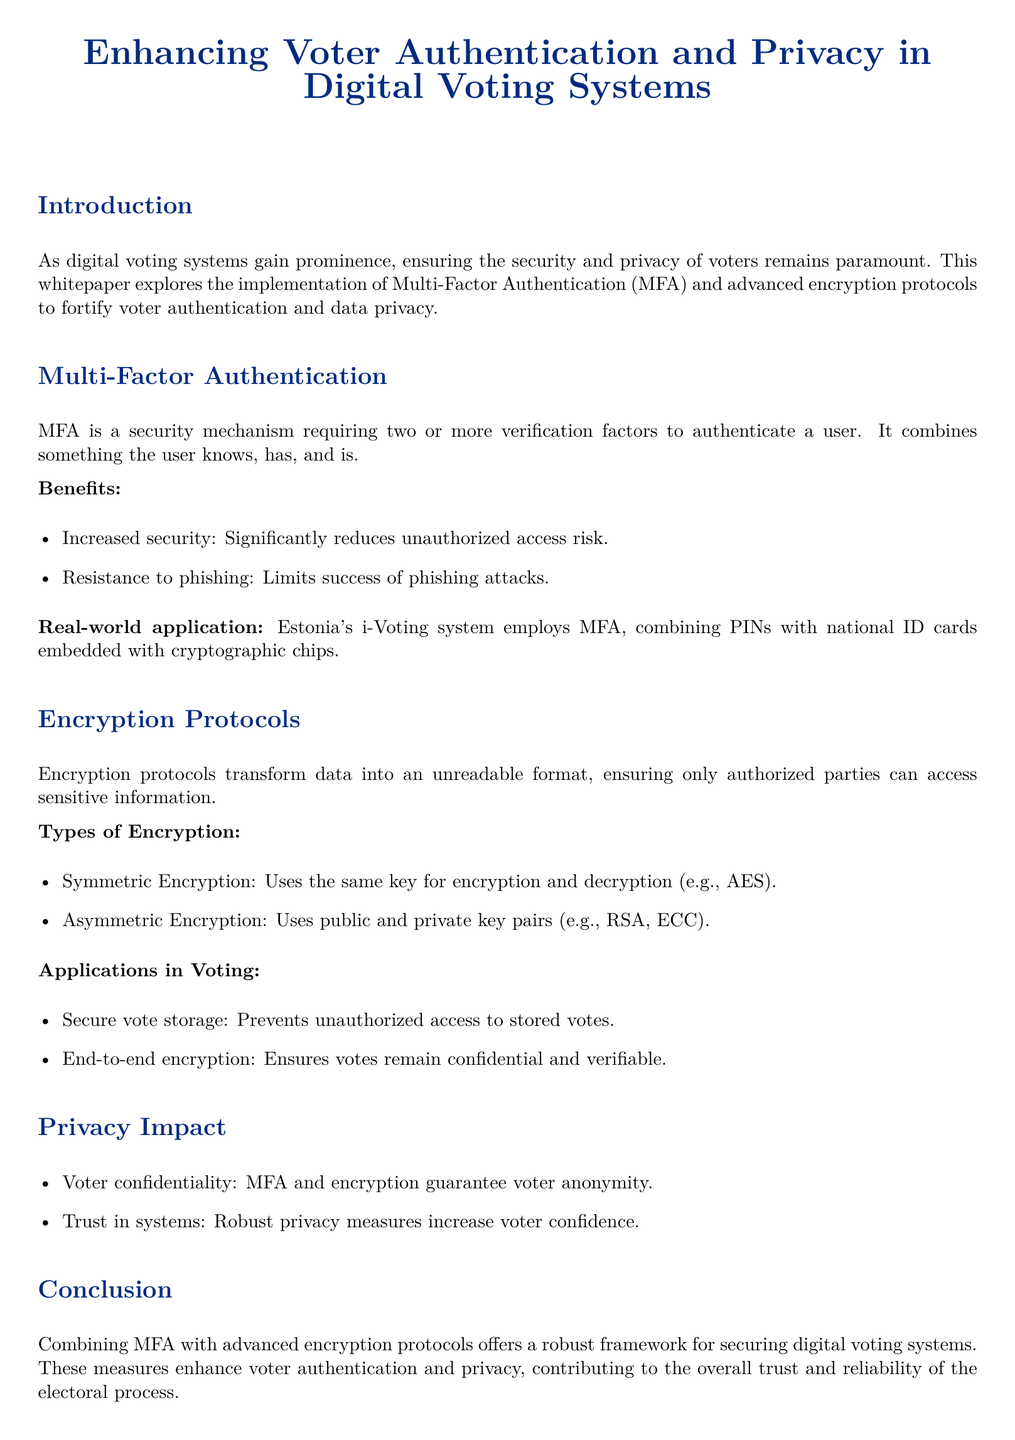What is the main focus of the whitepaper? The main focus of the whitepaper is on enhancing voter authentication and privacy in digital voting systems through MFA and encryption protocols.
Answer: enhancing voter authentication and privacy What does MFA stand for? MFA stands for Multi-Factor Authentication, which is a security mechanism.
Answer: Multi-Factor Authentication What is one real-world application of MFA mentioned in the document? The document mentions Estonia's i-Voting system as a real-world application of MFA.
Answer: Estonia's i-Voting system What are the two types of encryption discussed? The two types of encryption discussed are symmetric and asymmetric encryption.
Answer: symmetric and asymmetric What is a benefit of implementing MFA? One benefit of implementing MFA is increased security, which significantly reduces unauthorized access risk.
Answer: increased security How does encryption ensure voter confidentiality? Encryption transforms data into an unreadable format, ensuring only authorized parties can access sensitive information, maintaining voter confidentiality.
Answer: by transforming data into an unreadable format What is the relationship between privacy measures and voter trust? Robust privacy measures increase voter confidence in the digital voting system.
Answer: increase voter confidence What is the conclusion of the whitepaper? The conclusion is that combining MFA with advanced encryption protocols offers a robust framework for securing digital voting systems.
Answer: a robust framework for securing digital voting systems What type of document is this? This document is a whitepaper, which discusses the topic of digital voting systems and security.
Answer: whitepaper 